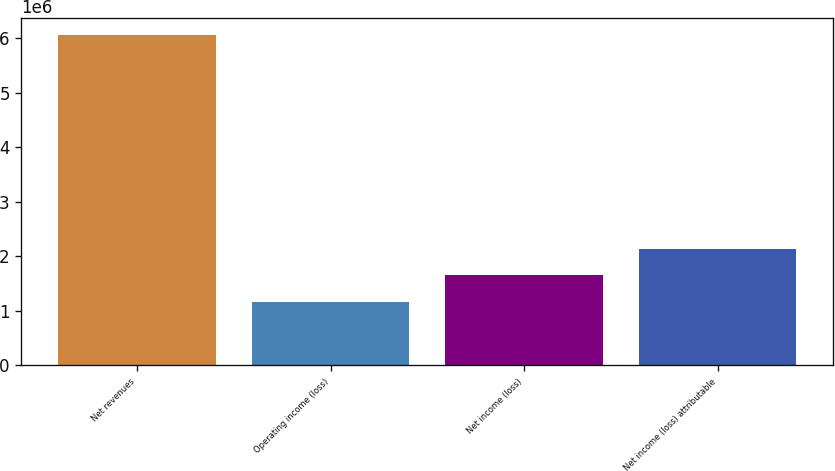<chart> <loc_0><loc_0><loc_500><loc_500><bar_chart><fcel>Net revenues<fcel>Operating income (loss)<fcel>Net income (loss)<fcel>Net income (loss) attributable<nl><fcel>6.056e+06<fcel>1.15893e+06<fcel>1.64864e+06<fcel>2.13834e+06<nl></chart> 